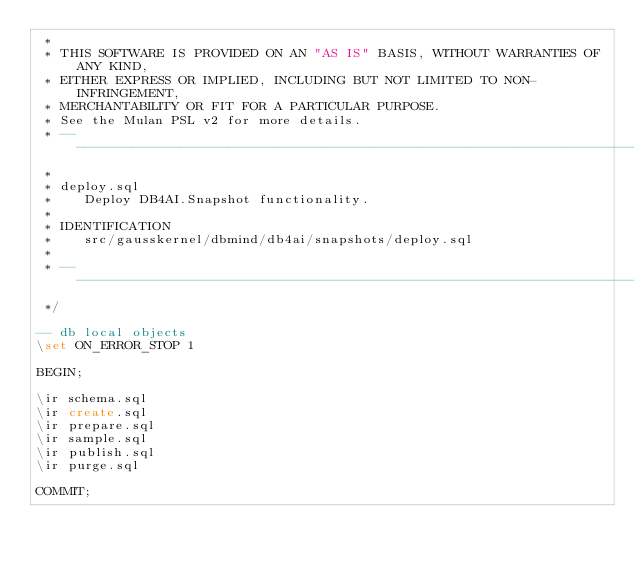Convert code to text. <code><loc_0><loc_0><loc_500><loc_500><_SQL_> *
 * THIS SOFTWARE IS PROVIDED ON AN "AS IS" BASIS, WITHOUT WARRANTIES OF ANY KIND,
 * EITHER EXPRESS OR IMPLIED, INCLUDING BUT NOT LIMITED TO NON-INFRINGEMENT,
 * MERCHANTABILITY OR FIT FOR A PARTICULAR PURPOSE.
 * See the Mulan PSL v2 for more details.
 * -------------------------------------------------------------------------
 *
 * deploy.sql
 *    Deploy DB4AI.Snapshot functionality.
 *
 * IDENTIFICATION
 *    src/gausskernel/dbmind/db4ai/snapshots/deploy.sql
 *
 * -------------------------------------------------------------------------
 */

-- db local objects
\set ON_ERROR_STOP 1

BEGIN;

\ir schema.sql
\ir create.sql
\ir prepare.sql
\ir sample.sql
\ir publish.sql
\ir purge.sql

COMMIT;
</code> 